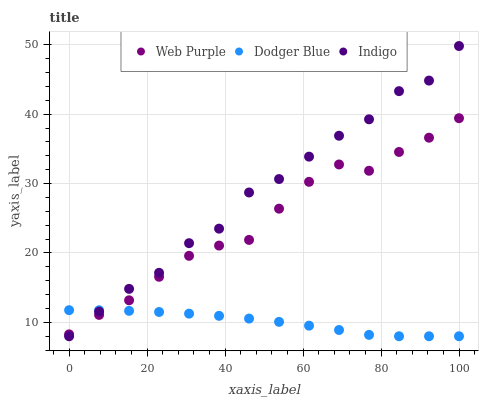Does Dodger Blue have the minimum area under the curve?
Answer yes or no. Yes. Does Indigo have the maximum area under the curve?
Answer yes or no. Yes. Does Web Purple have the minimum area under the curve?
Answer yes or no. No. Does Web Purple have the maximum area under the curve?
Answer yes or no. No. Is Dodger Blue the smoothest?
Answer yes or no. Yes. Is Indigo the roughest?
Answer yes or no. Yes. Is Web Purple the smoothest?
Answer yes or no. No. Is Web Purple the roughest?
Answer yes or no. No. Does Indigo have the lowest value?
Answer yes or no. Yes. Does Web Purple have the lowest value?
Answer yes or no. No. Does Indigo have the highest value?
Answer yes or no. Yes. Does Web Purple have the highest value?
Answer yes or no. No. Does Indigo intersect Dodger Blue?
Answer yes or no. Yes. Is Indigo less than Dodger Blue?
Answer yes or no. No. Is Indigo greater than Dodger Blue?
Answer yes or no. No. 